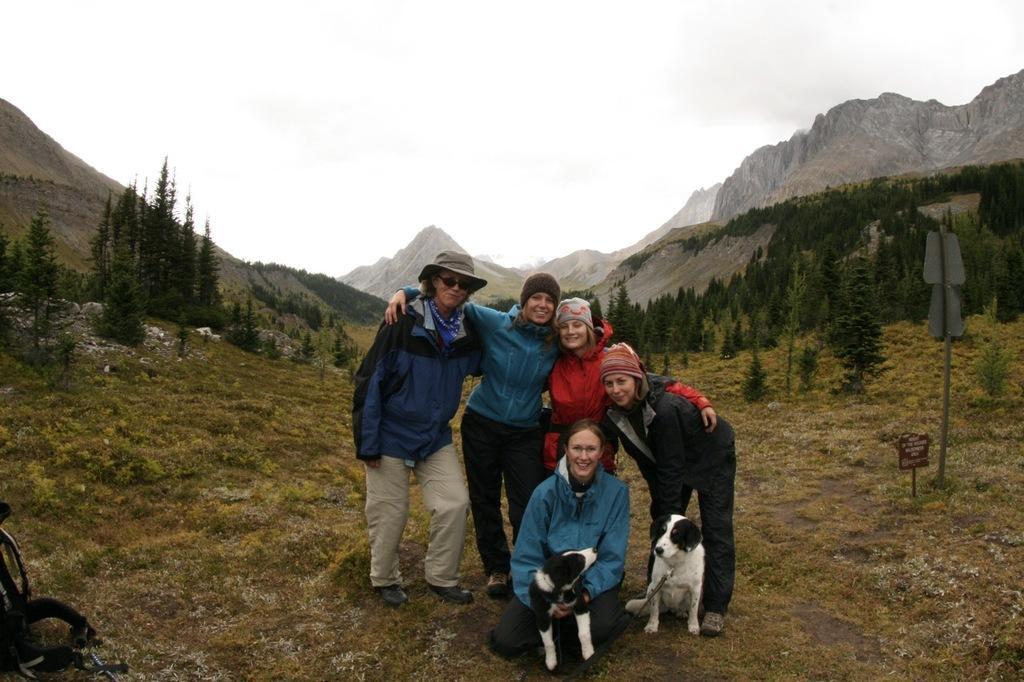In one or two sentences, can you explain what this image depicts? In the image there are few people in the foreground, they are posing for the photo and around them there is a grass surface and behind them there are trees and mountains. 